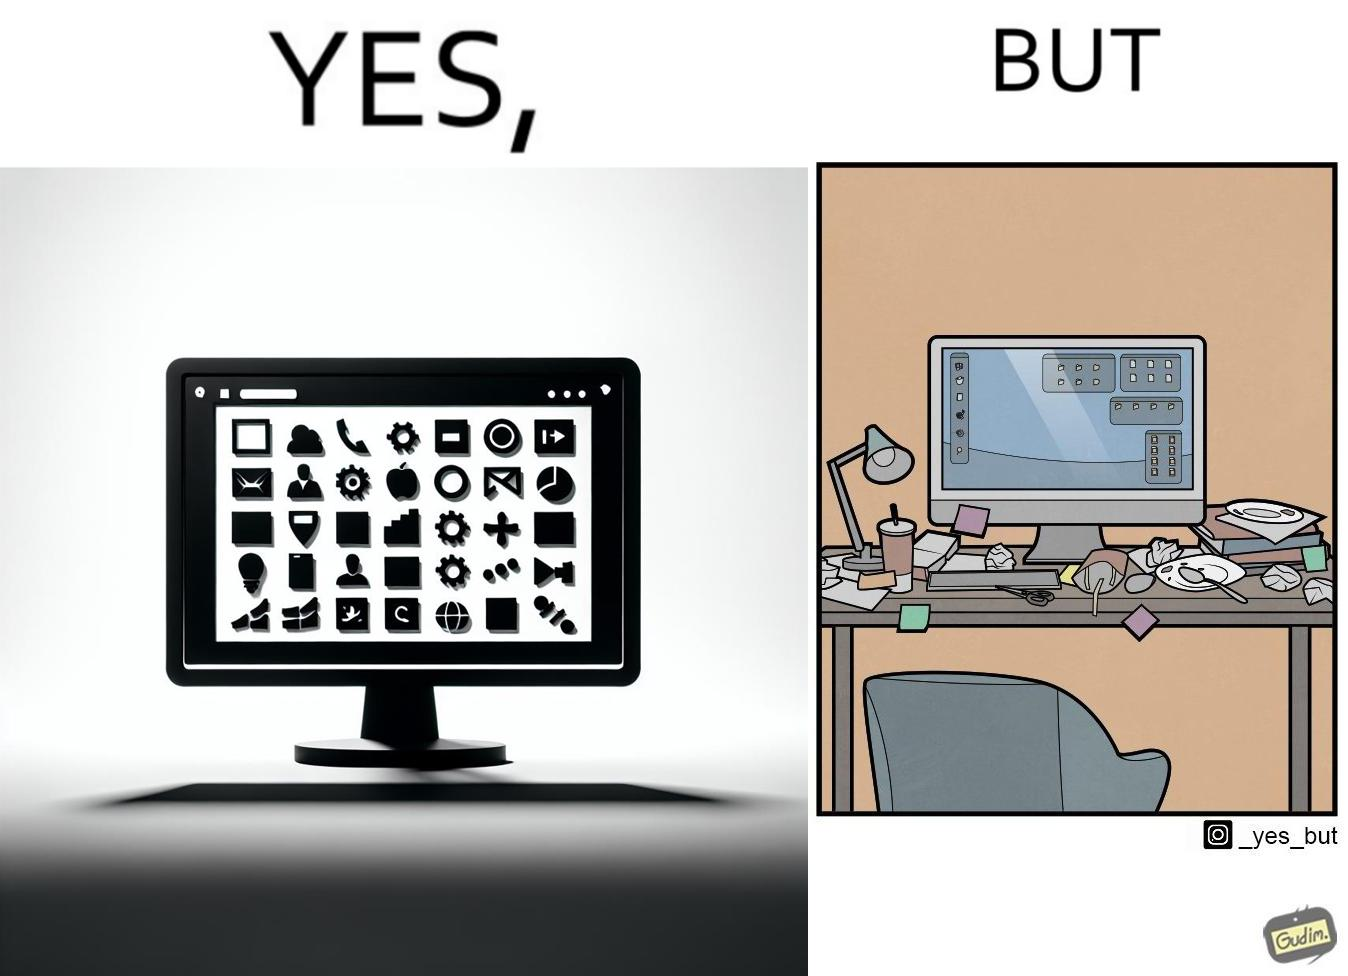Why is this image considered satirical? The image is ironical, as the folder icons on the desktop screen are very neatly arranged, while the person using the computer has littered the table with used food packets, dirty plates, and wrappers. 